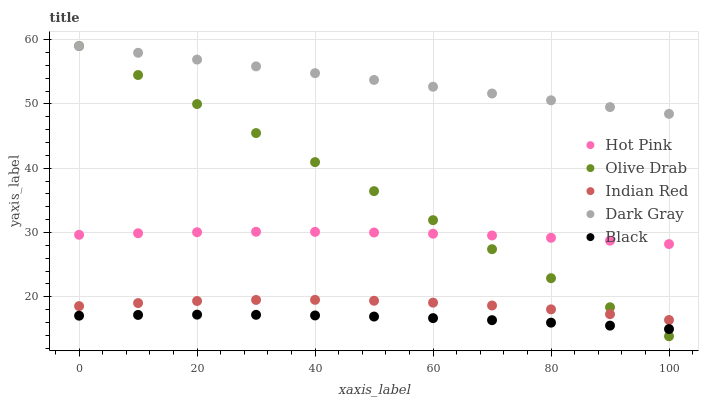Does Black have the minimum area under the curve?
Answer yes or no. Yes. Does Dark Gray have the maximum area under the curve?
Answer yes or no. Yes. Does Hot Pink have the minimum area under the curve?
Answer yes or no. No. Does Hot Pink have the maximum area under the curve?
Answer yes or no. No. Is Olive Drab the smoothest?
Answer yes or no. Yes. Is Indian Red the roughest?
Answer yes or no. Yes. Is Hot Pink the smoothest?
Answer yes or no. No. Is Hot Pink the roughest?
Answer yes or no. No. Does Olive Drab have the lowest value?
Answer yes or no. Yes. Does Hot Pink have the lowest value?
Answer yes or no. No. Does Olive Drab have the highest value?
Answer yes or no. Yes. Does Hot Pink have the highest value?
Answer yes or no. No. Is Hot Pink less than Dark Gray?
Answer yes or no. Yes. Is Indian Red greater than Black?
Answer yes or no. Yes. Does Olive Drab intersect Hot Pink?
Answer yes or no. Yes. Is Olive Drab less than Hot Pink?
Answer yes or no. No. Is Olive Drab greater than Hot Pink?
Answer yes or no. No. Does Hot Pink intersect Dark Gray?
Answer yes or no. No. 